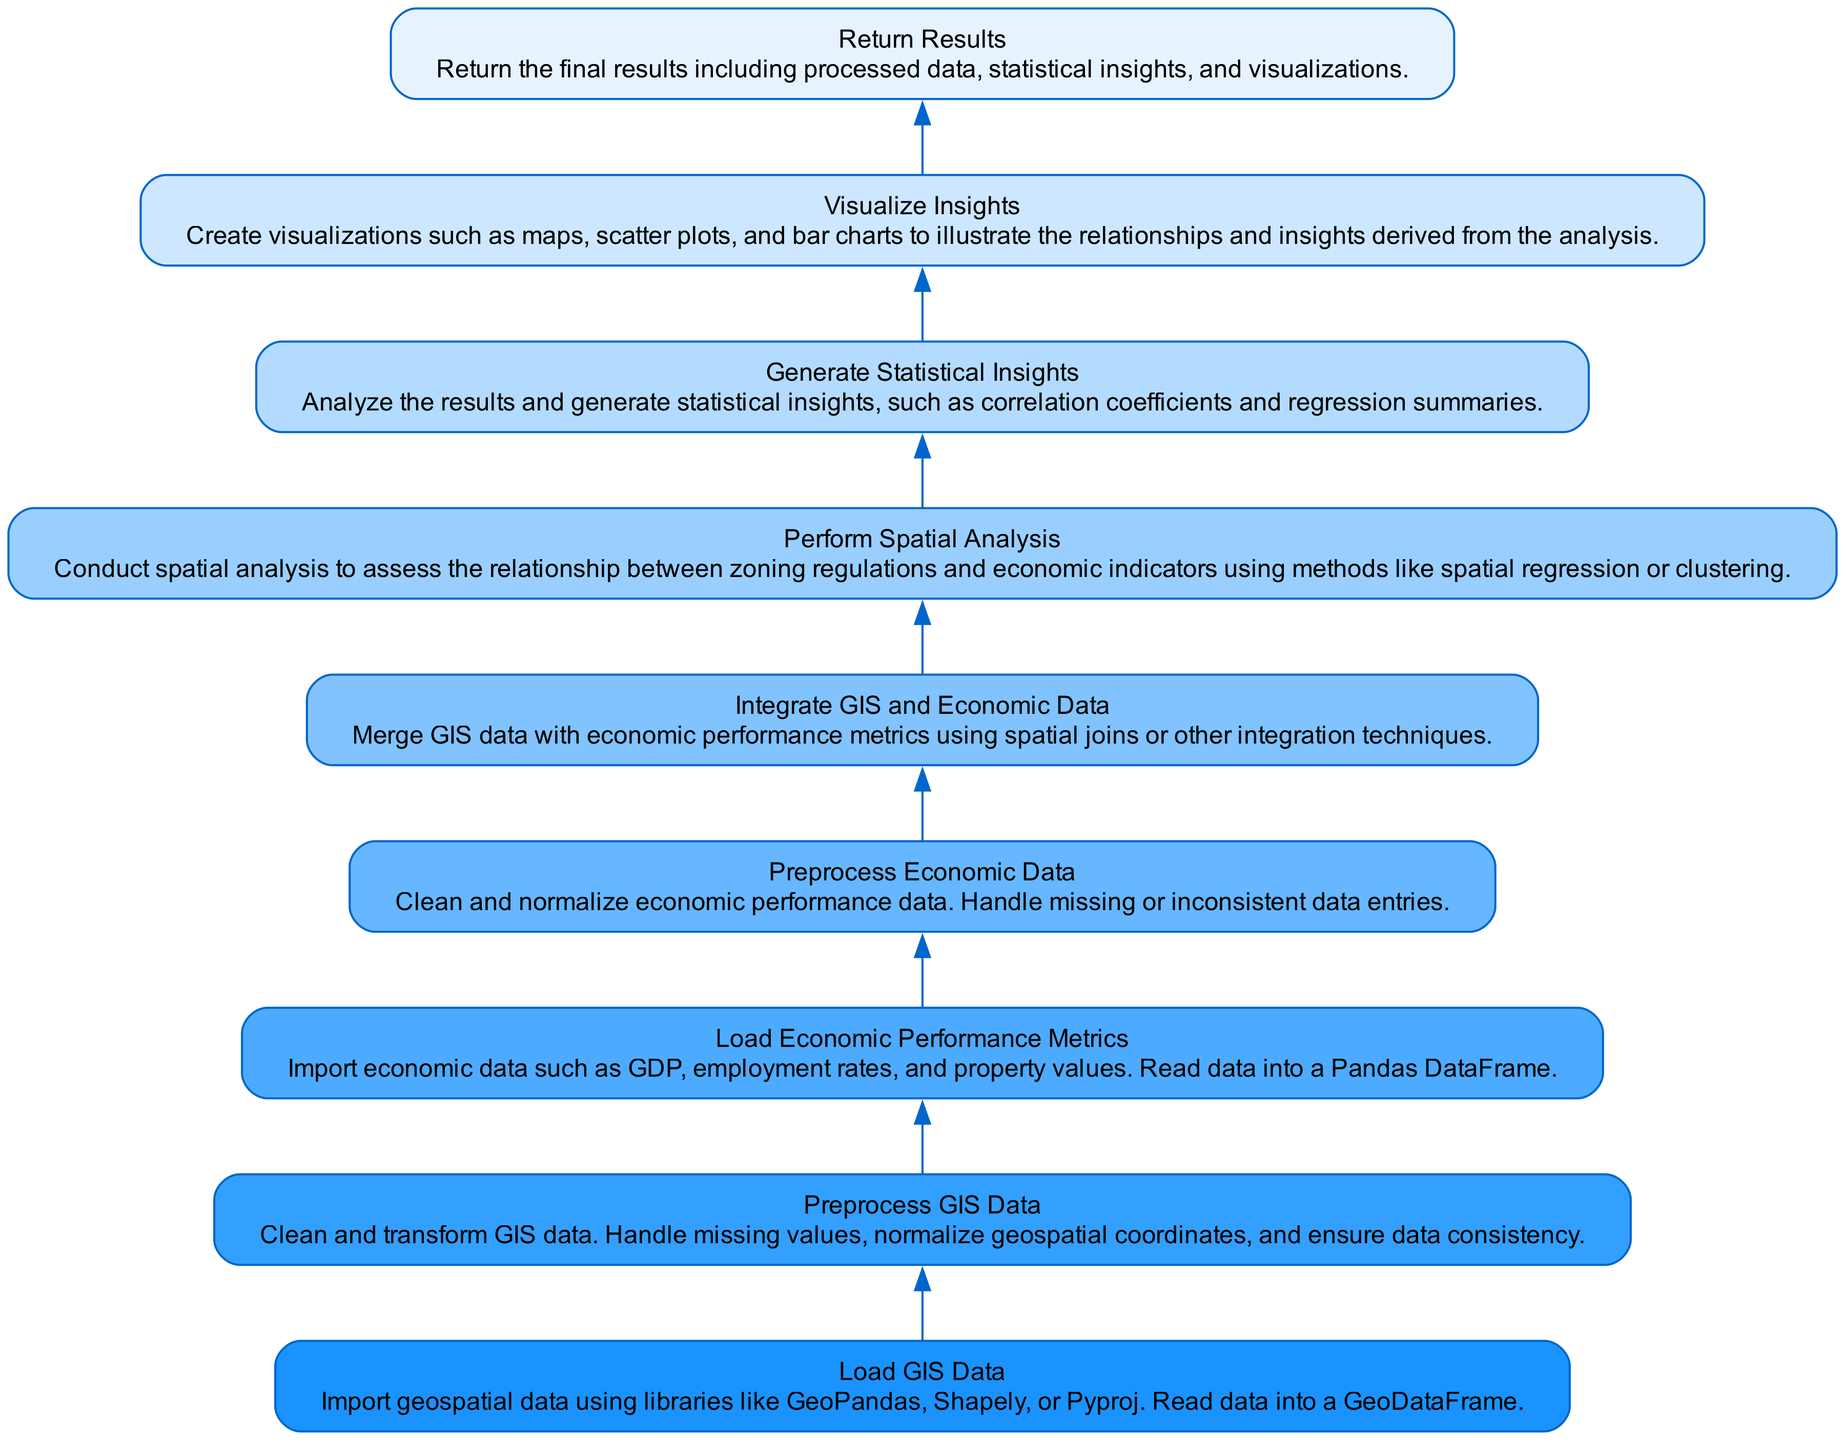What is the first step in the workflow? The first step in the workflow, as indicated at the bottom of the flowchart, is "Load GIS Data." This is the initial action taken before any data processing occurs.
Answer: Load GIS Data How many nodes are present in the diagram? The total number of elements listed in the diagram is nine, representing the different steps in the workflow. Each step is depicted as a node.
Answer: Nine What is the relationship between "Preprocess Economic Data" and "Integrate GIS and Economic Data"? The relationship is sequential; "Preprocess Economic Data" feeds into "Integrate GIS and Economic Data" as it prepares the economic metrics for integration. This indicates that preprocessing is essential before merging data.
Answer: Sequential What does the "Generate Statistical Insights" step follow? The "Generate Statistical Insights" step follows the "Perform Spatial Analysis" step. This indicates that analyzing the spatial data is completed before generating insights based on that analysis.
Answer: Perform Spatial Analysis Which step in the workflow deals with handling missing values? The steps that deal with handling missing values are "Preprocess GIS Data" and "Preprocess Economic Data." Both of these steps focus on cleaning and transforming data, which includes addressing missing entries.
Answer: Preprocess GIS Data, Preprocess Economic Data What action is taken after "Visualize Insights"? The action taken after "Visualize Insights" is to "Return Results." This indicates the workflow concludes with delivering the analyzed data and visual representations of insights.
Answer: Return Results What is the last step in the workflow? The last step in the workflow is "Return Results," which follows all the previous processes and finalizes the output of the analysis.
Answer: Return Results Which step directly integrates GIS and economic data? The step that directly integrates GIS and economic data is "Integrate GIS and Economic Data," demonstrating the point at which the two data types come together for analysis.
Answer: Integrate GIS and Economic Data How many edges are present in the diagram? The number of edges in the diagram is eight, which represent the connections between each of the nine nodes or steps, indicating the flow of the process.
Answer: Eight 